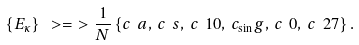Convert formula to latex. <formula><loc_0><loc_0><loc_500><loc_500>\{ E _ { \kappa } \} \ > = \ > \frac { 1 } { N } \left \{ c _ { \ } a , \, c _ { \ } s , \, c _ { \ } 1 0 , \, c _ { \sin } g , \, c _ { \ } 0 , \, c _ { \ } 2 7 \right \} .</formula> 